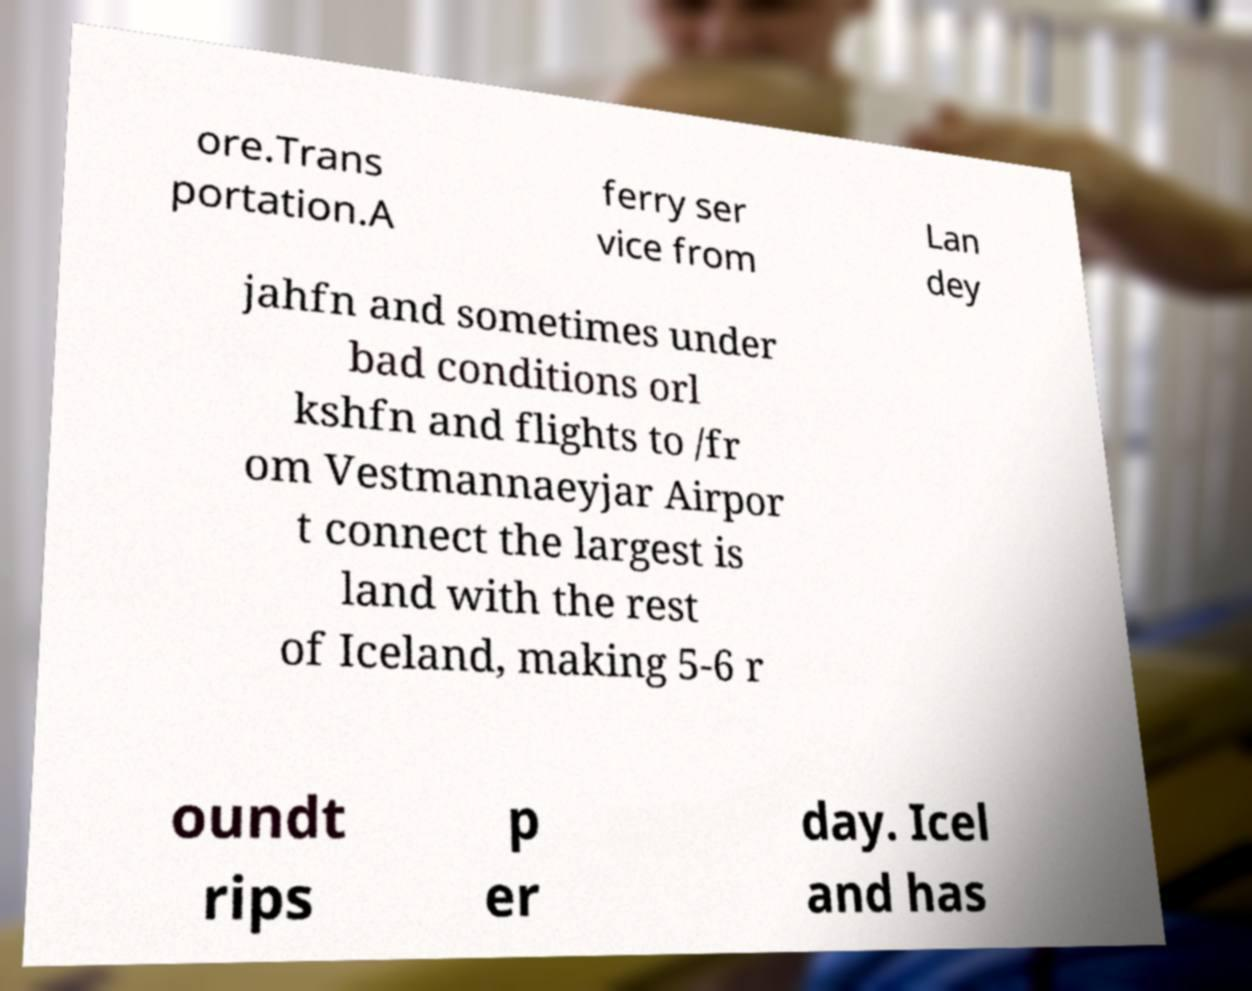Could you assist in decoding the text presented in this image and type it out clearly? ore.Trans portation.A ferry ser vice from Lan dey jahfn and sometimes under bad conditions orl kshfn and flights to /fr om Vestmannaeyjar Airpor t connect the largest is land with the rest of Iceland, making 5-6 r oundt rips p er day. Icel and has 